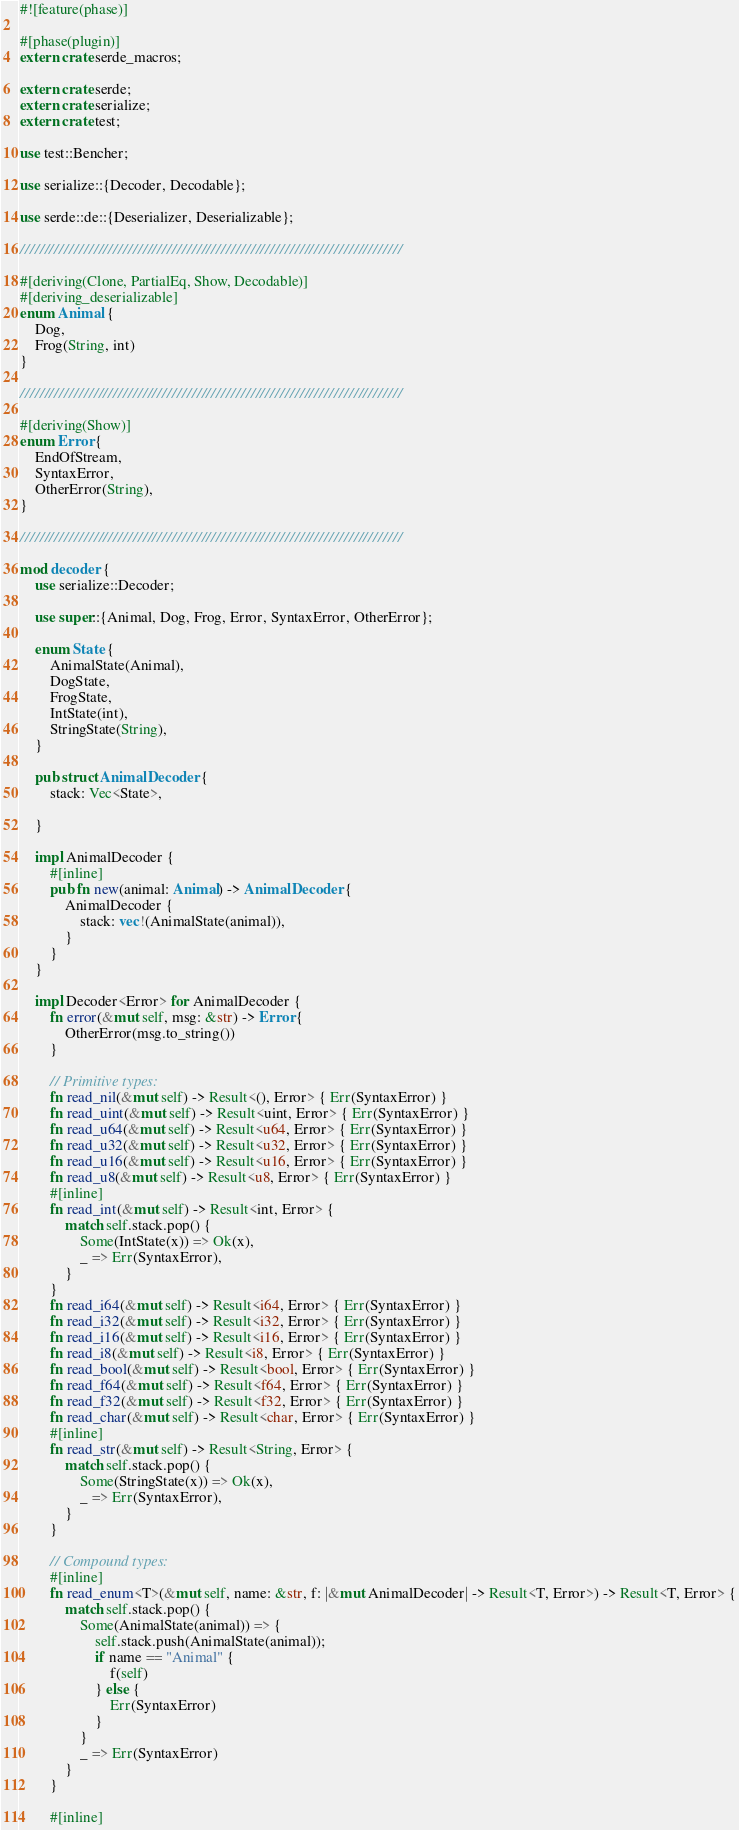<code> <loc_0><loc_0><loc_500><loc_500><_Rust_>#![feature(phase)]

#[phase(plugin)]
extern crate serde_macros;

extern crate serde;
extern crate serialize;
extern crate test;

use test::Bencher;

use serialize::{Decoder, Decodable};

use serde::de::{Deserializer, Deserializable};

//////////////////////////////////////////////////////////////////////////////

#[deriving(Clone, PartialEq, Show, Decodable)]
#[deriving_deserializable]
enum Animal {
    Dog,
    Frog(String, int)
}

//////////////////////////////////////////////////////////////////////////////

#[deriving(Show)]
enum Error {
    EndOfStream,
    SyntaxError,
    OtherError(String),
}

//////////////////////////////////////////////////////////////////////////////

mod decoder {
    use serialize::Decoder;

    use super::{Animal, Dog, Frog, Error, SyntaxError, OtherError};

    enum State {
        AnimalState(Animal),
        DogState,
        FrogState,
        IntState(int),
        StringState(String),
    }

    pub struct AnimalDecoder {
        stack: Vec<State>,

    }

    impl AnimalDecoder {
        #[inline]
        pub fn new(animal: Animal) -> AnimalDecoder {
            AnimalDecoder {
                stack: vec!(AnimalState(animal)),
            }
        }
    }

    impl Decoder<Error> for AnimalDecoder {
        fn error(&mut self, msg: &str) -> Error {
            OtherError(msg.to_string())
        }

        // Primitive types:
        fn read_nil(&mut self) -> Result<(), Error> { Err(SyntaxError) }
        fn read_uint(&mut self) -> Result<uint, Error> { Err(SyntaxError) }
        fn read_u64(&mut self) -> Result<u64, Error> { Err(SyntaxError) }
        fn read_u32(&mut self) -> Result<u32, Error> { Err(SyntaxError) }
        fn read_u16(&mut self) -> Result<u16, Error> { Err(SyntaxError) }
        fn read_u8(&mut self) -> Result<u8, Error> { Err(SyntaxError) }
        #[inline]
        fn read_int(&mut self) -> Result<int, Error> {
            match self.stack.pop() {
                Some(IntState(x)) => Ok(x),
                _ => Err(SyntaxError),
            }
        }
        fn read_i64(&mut self) -> Result<i64, Error> { Err(SyntaxError) }
        fn read_i32(&mut self) -> Result<i32, Error> { Err(SyntaxError) }
        fn read_i16(&mut self) -> Result<i16, Error> { Err(SyntaxError) }
        fn read_i8(&mut self) -> Result<i8, Error> { Err(SyntaxError) }
        fn read_bool(&mut self) -> Result<bool, Error> { Err(SyntaxError) }
        fn read_f64(&mut self) -> Result<f64, Error> { Err(SyntaxError) }
        fn read_f32(&mut self) -> Result<f32, Error> { Err(SyntaxError) }
        fn read_char(&mut self) -> Result<char, Error> { Err(SyntaxError) }
        #[inline]
        fn read_str(&mut self) -> Result<String, Error> {
            match self.stack.pop() {
                Some(StringState(x)) => Ok(x),
                _ => Err(SyntaxError),
            }
        }

        // Compound types:
        #[inline]
        fn read_enum<T>(&mut self, name: &str, f: |&mut AnimalDecoder| -> Result<T, Error>) -> Result<T, Error> {
            match self.stack.pop() {
                Some(AnimalState(animal)) => {
                    self.stack.push(AnimalState(animal));
                    if name == "Animal" {
                        f(self)
                    } else {
                        Err(SyntaxError)
                    }
                }
                _ => Err(SyntaxError)
            }
        }

        #[inline]</code> 